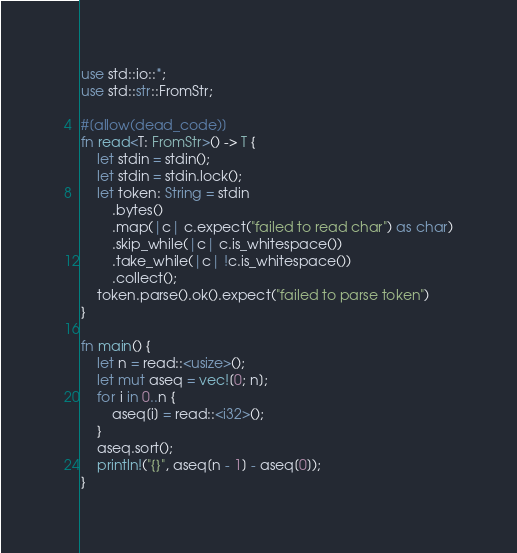<code> <loc_0><loc_0><loc_500><loc_500><_Rust_>use std::io::*;
use std::str::FromStr;

#[allow(dead_code)]
fn read<T: FromStr>() -> T {
    let stdin = stdin();
    let stdin = stdin.lock();
    let token: String = stdin
        .bytes()
        .map(|c| c.expect("failed to read char") as char)
        .skip_while(|c| c.is_whitespace())
        .take_while(|c| !c.is_whitespace())
        .collect();
    token.parse().ok().expect("failed to parse token")
}

fn main() {
    let n = read::<usize>();
    let mut aseq = vec![0; n];
    for i in 0..n {
        aseq[i] = read::<i32>();
    }
    aseq.sort();
    println!("{}", aseq[n - 1] - aseq[0]);
}
</code> 